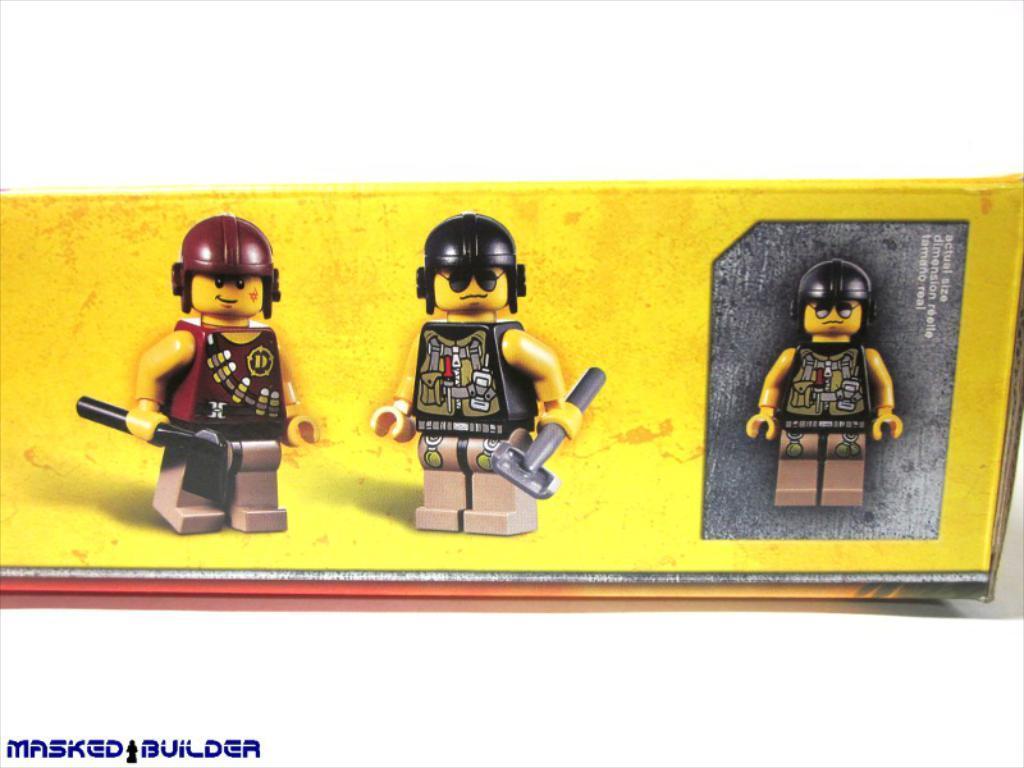In one or two sentences, can you explain what this image depicts? In the middle of the image there are three toys on the cardboard box and there is a text on it. In this image the background is white in color. 